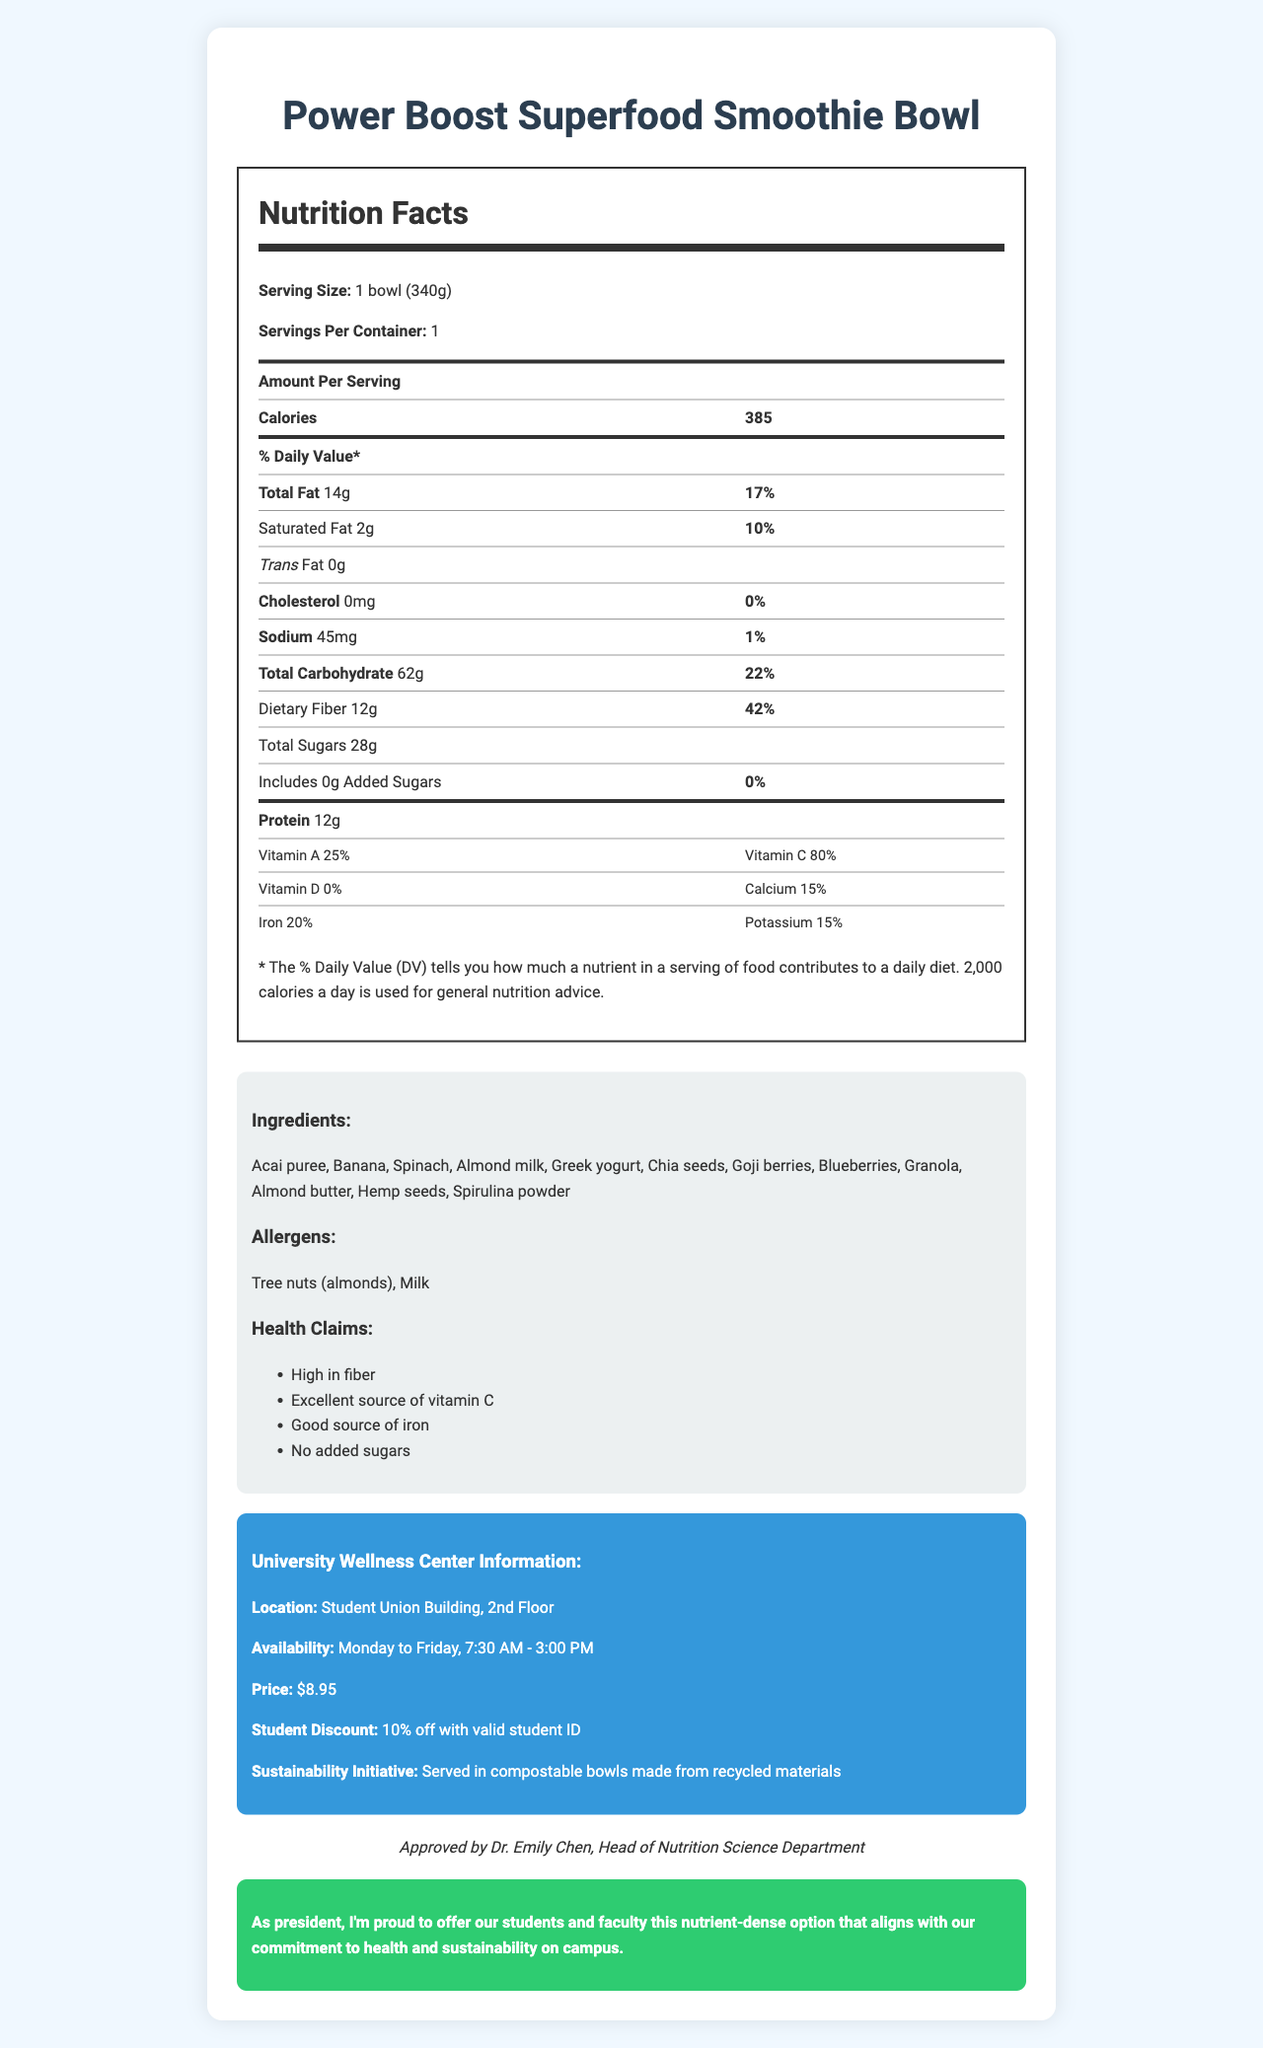what is the serving size of the Power Boost Superfood Smoothie Bowl? The serving size is clearly listed at the top of the nutrition facts section as "1 bowl (340g)".
Answer: 1 bowl (340g) how many calories does one serving of the Power Boost Superfood Smoothie Bowl contain? The number of calories is listed in the nutrition facts section, indicating 385 calories per serving.
Answer: 385 what is the total fat content per serving? The total fat content per serving is listed in the nutrition facts section as "Total Fat 14g".
Answer: 14g how much dietary fiber does the smoothie bowl have per serving? The dietary fiber content is listed as "Dietary Fiber 12g" in the nutrition facts section.
Answer: 12g list three ingredients included in the Power Boost Superfood Smoothie Bowl? The ingredients are listed in the ingredients section, with Acai puree, Banana, and Spinach being a few of them.
Answer: Acai puree, Banana, Spinach Does the Power Boost Superfood Smoothie Bowl contain any added sugars? According to the nutrition facts section under total sugars, it states "Includes 0g Added Sugars".
Answer: No Is the sodium content in the Power Boost Superfood Smoothie Bowl high or low? The sodium content is listed as 45mg, which is relatively low compared to daily value recommendations.
Answer: Low What allergens are present in the Power Boost Superfood Smoothie Bowl? A. Peanuts and Soy B. Wheat and Shellfish C. Tree nuts (almonds) and Milk The allergens section specifies that the smoothie bowl contains "Tree nuts (almonds)" and "Milk".
Answer: C Where is the university's wellness center located? A. Library B. Student Union Building, 2nd Floor C. Sports Complex The location is mentioned in the university-specific info section as "Student Union Building, 2nd Floor."
Answer: B What discount is offered to students with a valid ID? A. 5% off B. 10% off C. 15% off The university-specific info section mentions a "10% off with valid student ID."
Answer: B Is the Power Boost Superfood Smoothie Bowl served in compostable bowls? The sustainability initiative section of the document specifies that the smoothie bowl is "Served in compostable bowls made from recycled materials."
Answer: Yes Summarize the main idea of the document. This summary captures the essential information presented in the document: nutritional details, ingredients, allergens, health claims, and university-specific information regarding the wellness center and sustainability efforts.
Answer: The document provides detailed nutritional information about the Power Boost Superfood Smoothie Bowl served at the university's wellness center. It includes data on serving size, calorie count, and various nutrients. It also lists ingredients and allergens and highlights health claims like being high in fiber and containing no added sugars. Additionally, it provides information about the wellness center's location, operational hours, price, student discount, and sustainability initiatives. How many calories come from fat in one serving of the smoothie bowl? The document provides the total calories and the total fat content but does not specify the number of calories derived specifically from fat.
Answer: Cannot be determined Who approved the Power Boost Superfood Smoothie Bowl? The endorsement section clearly states that the smoothie bowl is "Approved by Dr. Emily Chen, Head of Nutrition Science Department."
Answer: Dr. Emily Chen, Head of Nutrition Science Department What is the percentage of the daily value of sodium provided by the smoothie bowl? The nutrition facts section calculates the sodium content as 45mg and mentions that it is 2% of the daily value.
Answer: 2% What is the wellness center's operation time from Monday to Friday? The university-specific info section under availability states the operating hours as "Monday to Friday, 7:30 AM - 3:00 PM."
Answer: 7:30 AM - 3:00 PM What percentage of Vitamin C does one serving provide? The nutrition facts section lists the Vitamin C content as 80% of the daily value.
Answer: 80% 